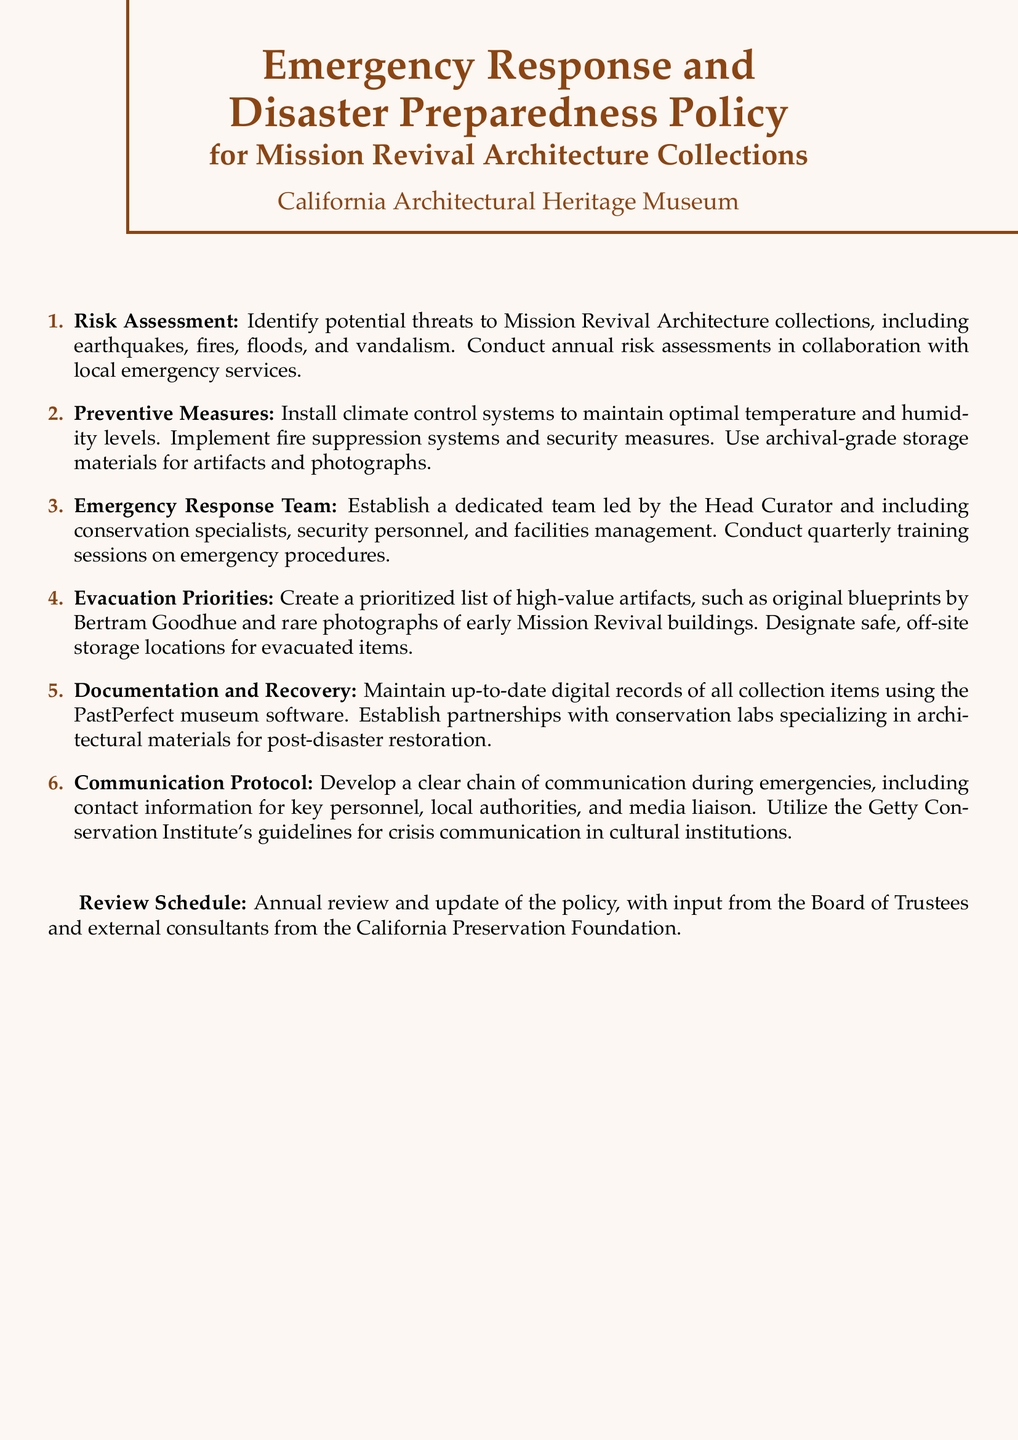What is the title of the document? The title is the main heading at the top of the document which outlines the content focus regarding emergency preparedness.
Answer: Emergency Response and Disaster Preparedness Policy for Mission Revival Architecture Collections How often should risk assessments be conducted? The document specifies the frequency of risk assessments which is mentioned in the risk assessment section.
Answer: Annual Who leads the Emergency Response Team? This role is outlined in the emergency response team section, indicating the head of the team.
Answer: Head Curator What materials should be used for artifact storage? This detail is found in the preventive measures section, which specifies the type of materials to be used.
Answer: Archival-grade storage materials What is the purpose of the communication protocol? The document discusses this protocol's aim in terms of emergency responses within its specific section.
Answer: Clear chain of communication What organization’s guidelines are referenced for crisis communication? The document mentions an external resource for crisis communication guidelines in the communication protocol section.
Answer: Getty Conservation Institute 